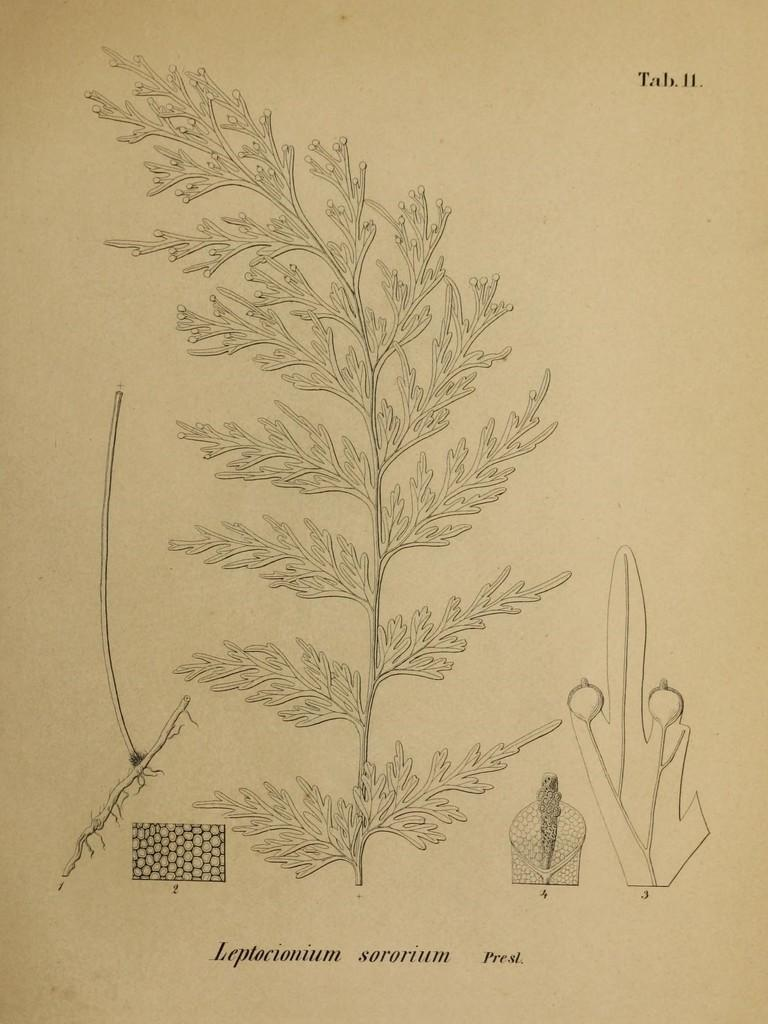What type of visual representation is the image? The image is a poster. What is depicted on the poster? There is a depiction of a leaf in the image. What else can be seen in the image besides the leaf? There are objects in the image. Where is text located on the poster? There is text on the top and bottom of the image. Can you hear the horn in the image? There is no horn present in the image, so it cannot be heard. What type of ocean is depicted in the image? There is no ocean depicted in the image; it features a poster with a leaf and text. 